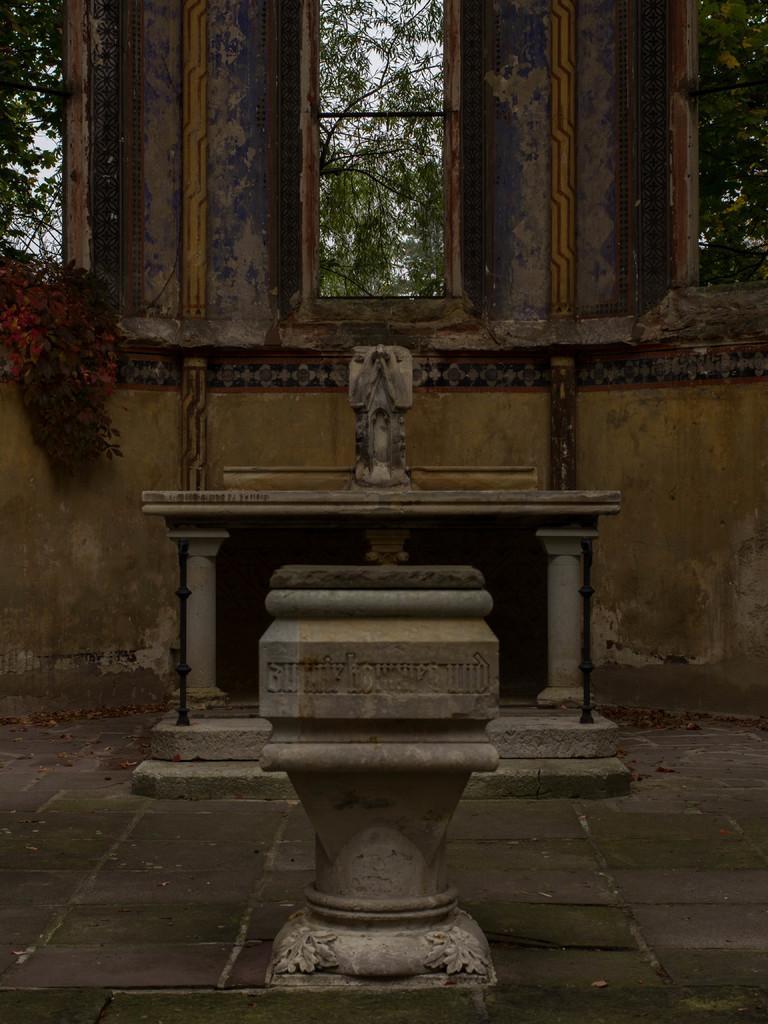How would you summarize this image in a sentence or two? In this aimeg, we can see walls, windows, trees, carving, few objects, stairs and floor. Here we can see black color rods. 